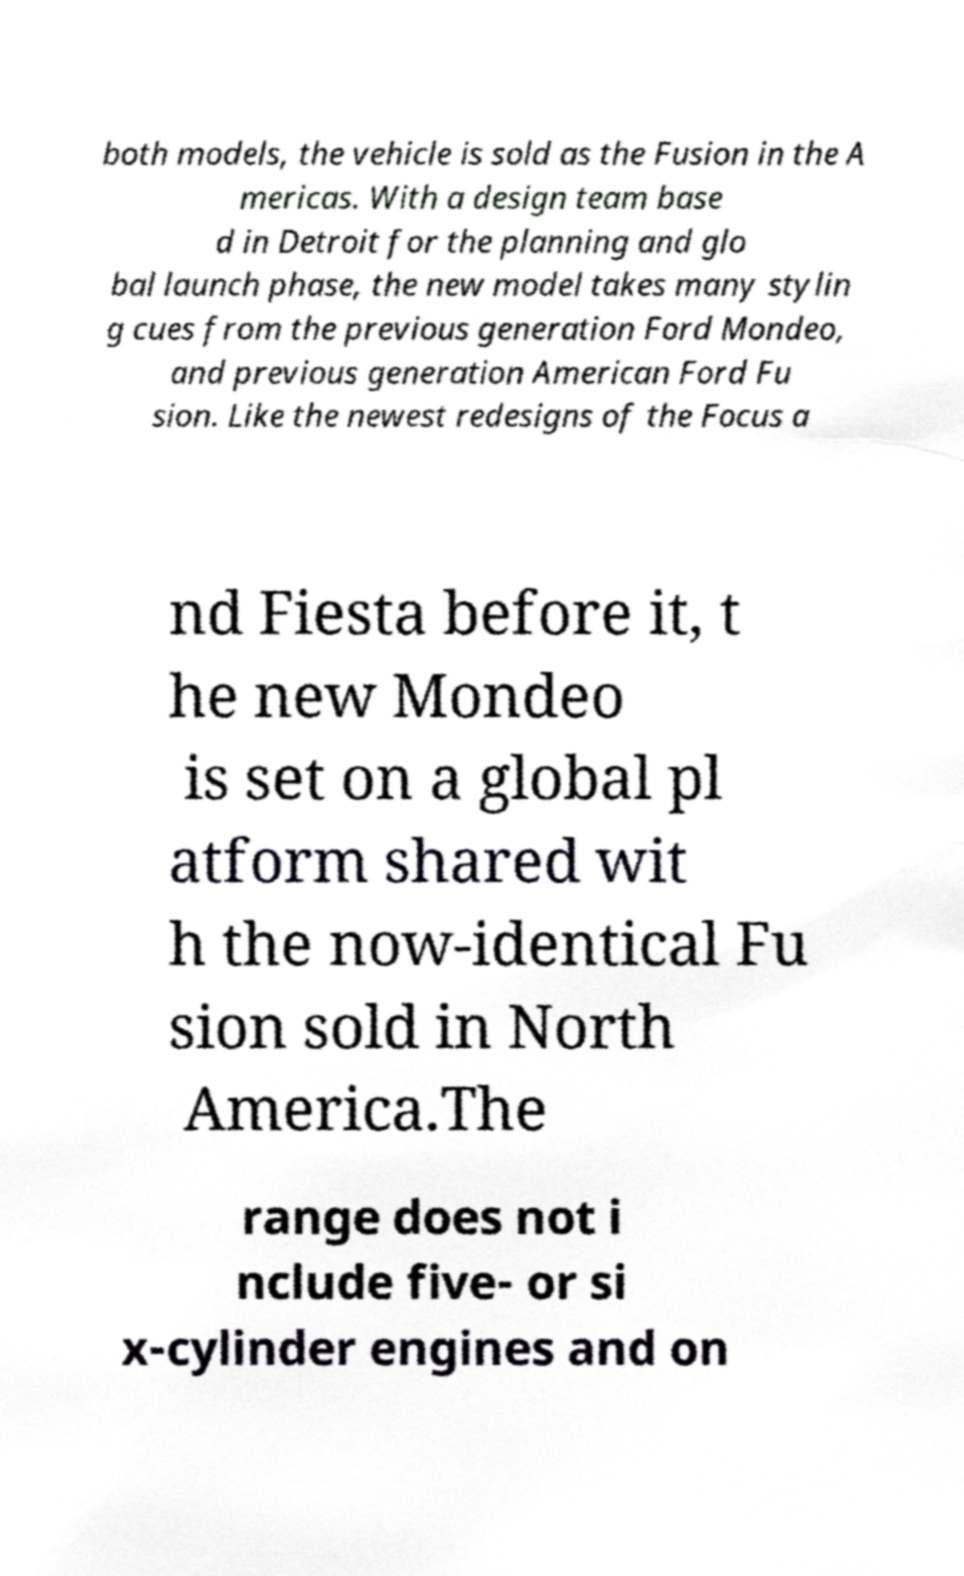Please identify and transcribe the text found in this image. both models, the vehicle is sold as the Fusion in the A mericas. With a design team base d in Detroit for the planning and glo bal launch phase, the new model takes many stylin g cues from the previous generation Ford Mondeo, and previous generation American Ford Fu sion. Like the newest redesigns of the Focus a nd Fiesta before it, t he new Mondeo is set on a global pl atform shared wit h the now-identical Fu sion sold in North America.The range does not i nclude five- or si x-cylinder engines and on 